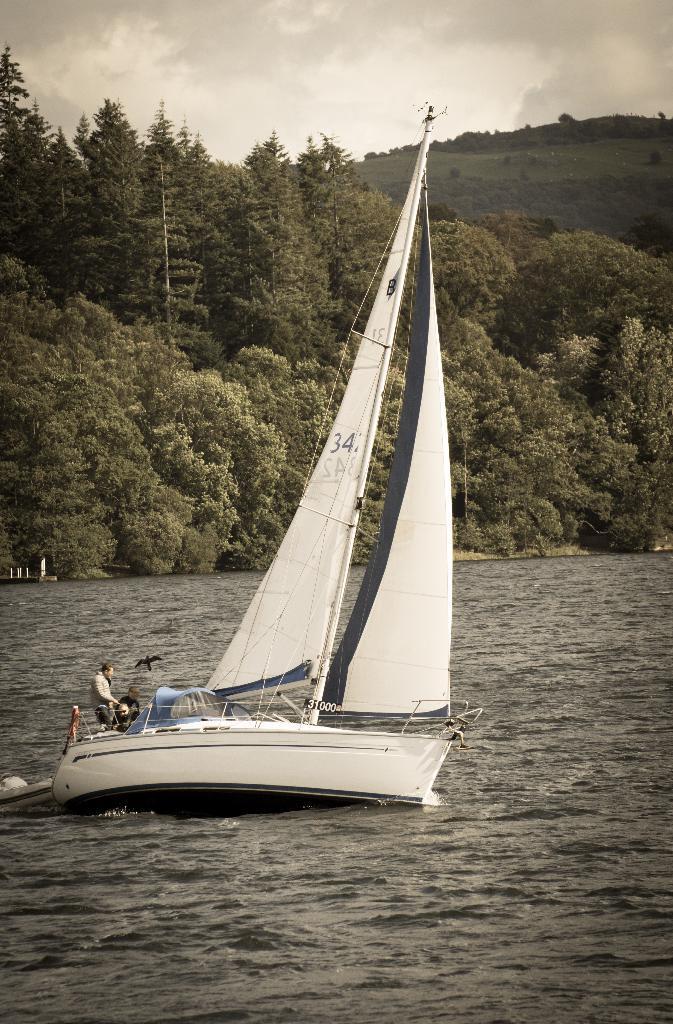Could you give a brief overview of what you see in this image? In this image, we can see water, there is a white color boat on the water, we can see a person sitting in the boat, in the background there are some green color trees, at the top there is a sky. 